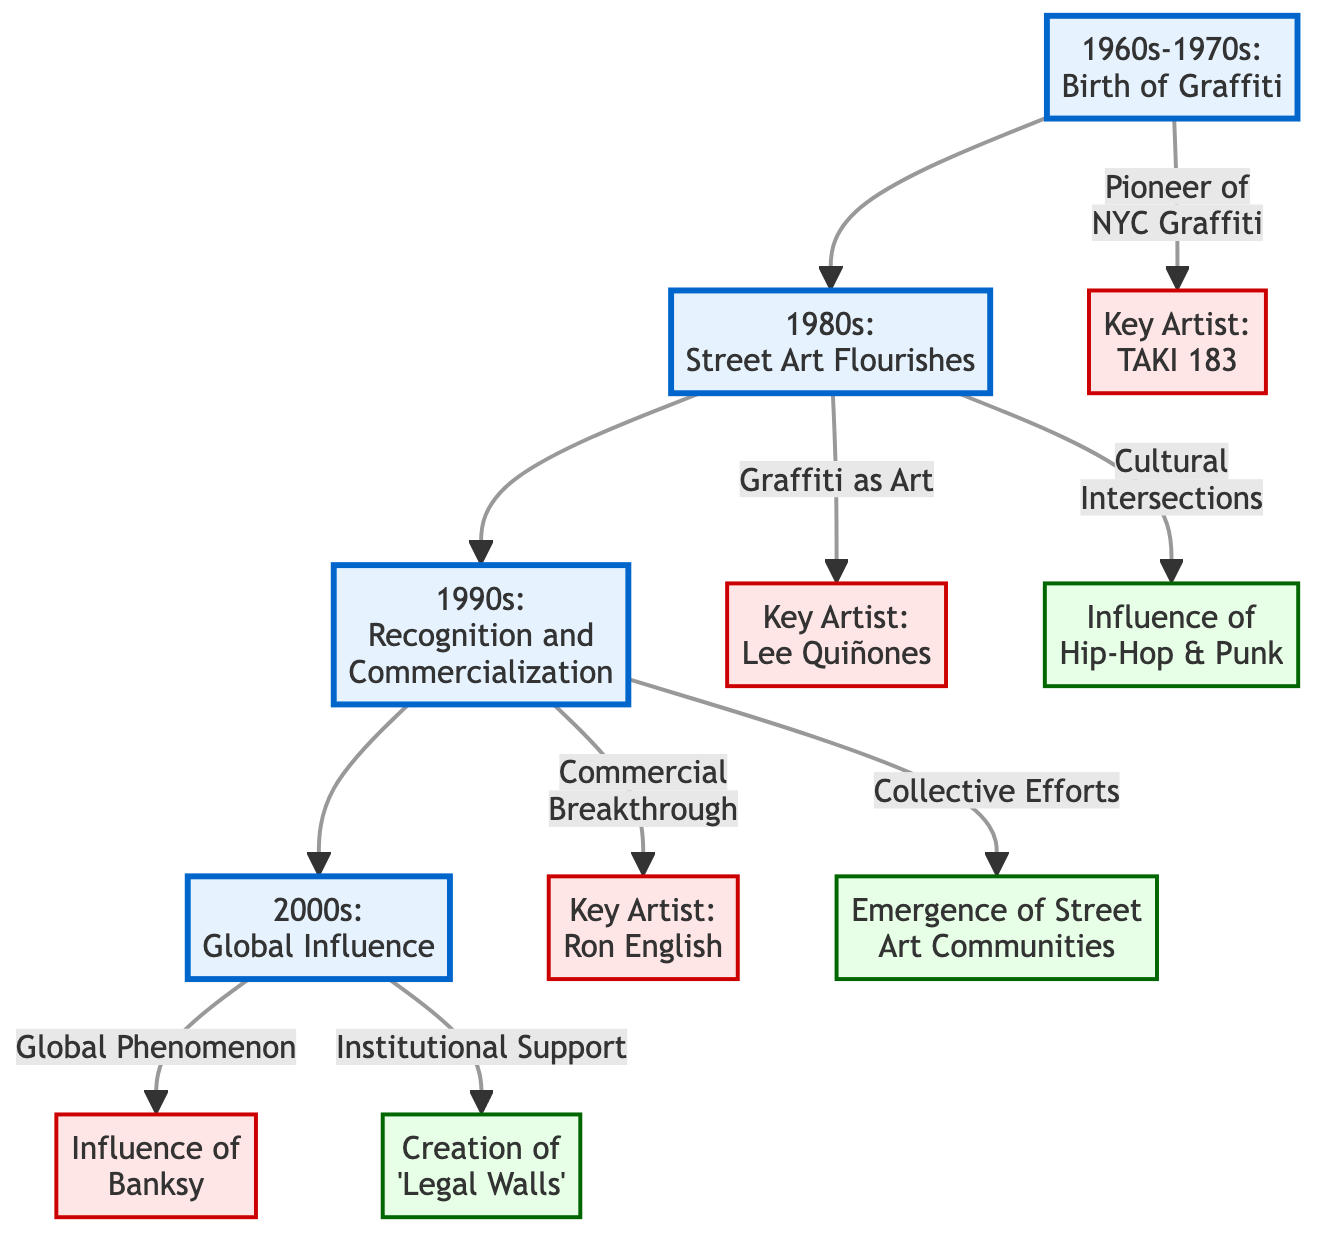What major art movement began in the 1960s? The diagram displays "1960s-1970s: Birth of Graffiti" as a key event from that decade. Therefore, the major art movement that began in the 1960s is graffiti.
Answer: graffiti Who was a key artist in the 1980s? From the diagram, it's indicated that Lee Quiñones is listed as a key artist associated with the 1980s. Therefore, the key artist in that decade is Lee Quiñones.
Answer: Lee Quiñones What influence emerged in the 1990s? The diagram shows "Collective Efforts" as an influence in 1990s, signifying that this influence emerged during that decade.
Answer: Collective Efforts Which artist is associated with global influence in the 2000s? According to the diagram, Banksy is explicitly noted for his global phenomenon influence during the 2000s. Hence, the artist associated with global influence in that decade is Banksy.
Answer: Banksy How many decades are represented in the diagram? The diagram presents four distinct decades: 1960s, 1980s, 1990s, and 2000s. Therefore, the number of decades represented in the diagram is four.
Answer: four Which influence relates to the creation of 'Legal Walls'? The diagram highlights "Creation of 'Legal Walls'" under the 2000s, making it clear that this refers to an influence in that time period.
Answer: Creation of 'Legal Walls' What was a significant factor for street art in the 1990s? The diagram notes "Commercial Breakthrough" under the 1990s, indicating that it was a significant factor for street art during that decade.
Answer: Commercial Breakthrough What connection does Hip-Hop have with street art? The diagram connects Hip-Hop with the cultural intersections occurring in the 1980s, showing that Hip-Hop significantly influenced the street art movement at that time.
Answer: Cultural Intersections Which key artist was a pioneer of NYC graffiti? Taki 183 is specifically identified as the "Pioneer of NYC Graffiti" in the 1960s according to the diagram. Thus, the key artist who was a pioneer is Taki 183.
Answer: Taki 183 